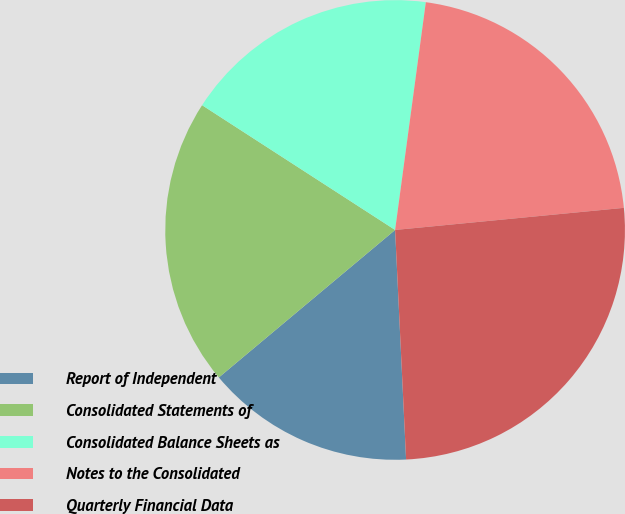Convert chart to OTSL. <chart><loc_0><loc_0><loc_500><loc_500><pie_chart><fcel>Report of Independent<fcel>Consolidated Statements of<fcel>Consolidated Balance Sheets as<fcel>Notes to the Consolidated<fcel>Quarterly Financial Data<nl><fcel>14.67%<fcel>20.22%<fcel>18.0%<fcel>21.33%<fcel>25.77%<nl></chart> 